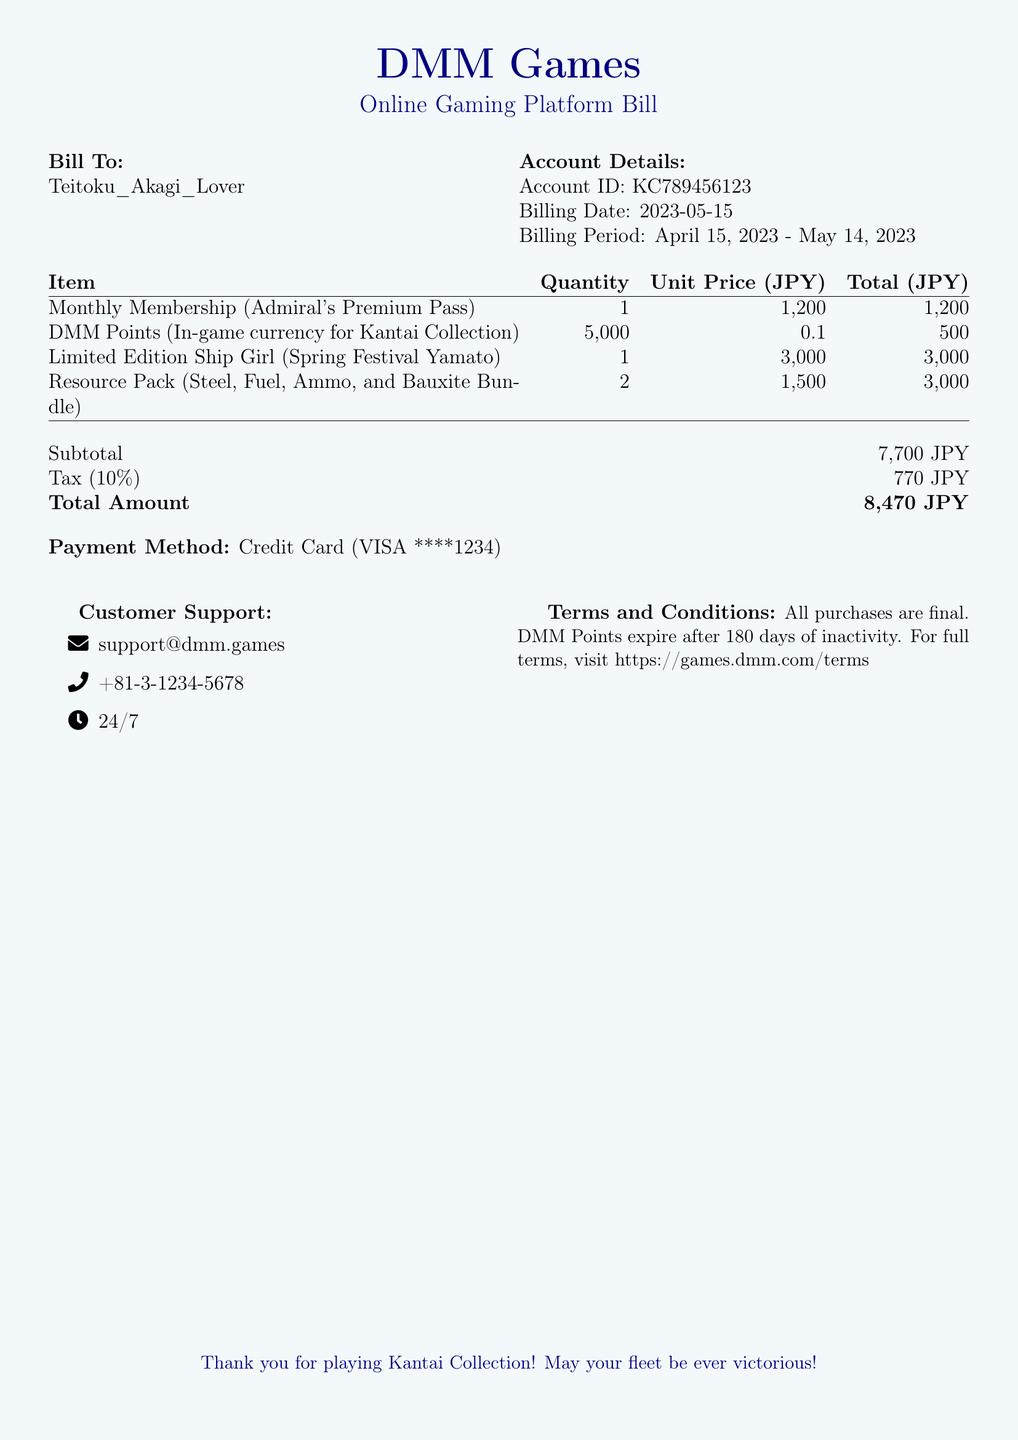What is the account ID? The account ID is listed under Account Details in the document.
Answer: KC789456123 What is the total amount due? The total amount due is clearly stated in the summary of costs at the bottom of the document.
Answer: 8,470 JPY How many DMM Points were purchased? The quantity of DMM Points is specified in the itemized list of purchases in the document.
Answer: 5,000 What is the tax rate applied? The tax rate is mentioned in the summary and is used to calculate the tax amount.
Answer: 10% What items were included in the purchases? The items are listed in the itemized table, outlining each item purchased in the bill.
Answer: Monthly Membership, DMM Points, Limited Edition Ship Girl, Resource Pack What is the payment method used? The payment method is stated explicitly in the bill details section.
Answer: Credit Card (VISA ****1234) What is the billing date? The billing date is provided in the Account Details section of the document.
Answer: 2023-05-15 What customer support contact method is provided? The contact methods for customer support are listed under that specific section in the document.
Answer: support@dmm.games 